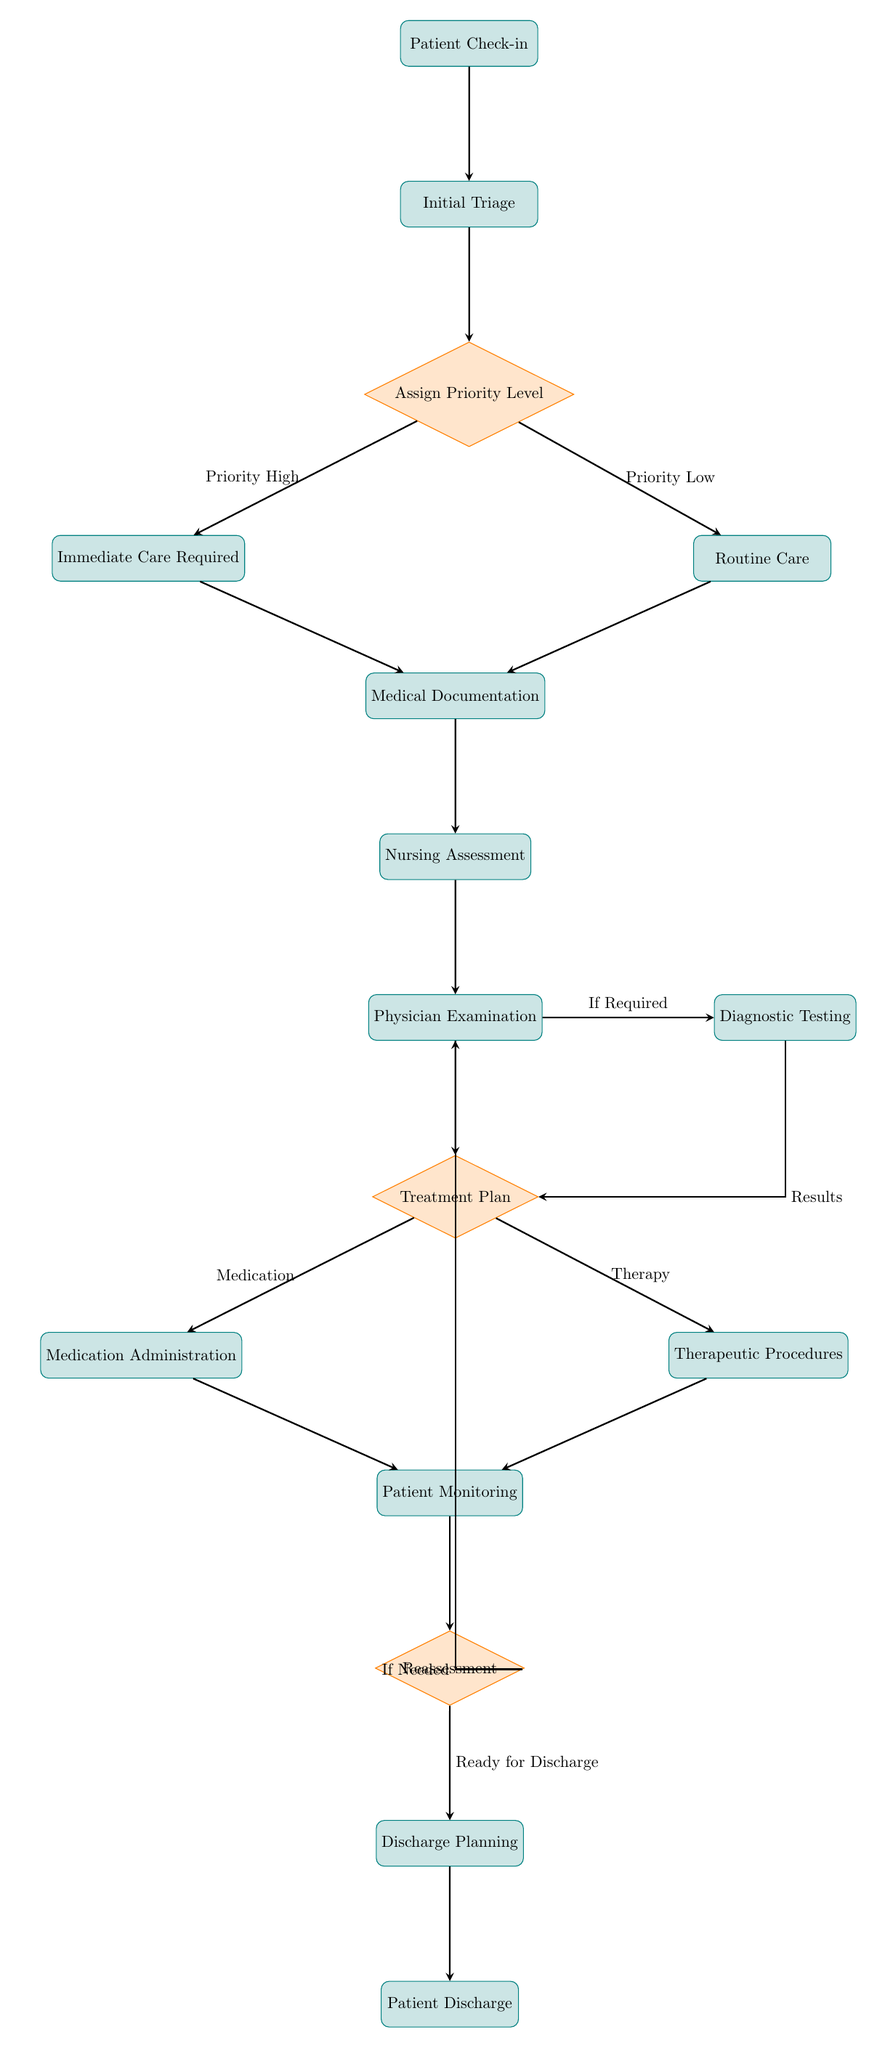What is the first step in the patient care workflow? The first step, according to the flowchart, is "Patient Check-in," which is the starting point of the process.
Answer: Patient Check-in How many decision points are in the diagram? Upon reviewing the flowchart, there are four decision points marked as diamonds. These are "Assign Priority Level," "Treatment Plan," and "Reassessment," which affect the flow of the process.
Answer: 4 What happens if immediate care is required? If "Immediate Care Required" is selected at the "Assign Priority Level" decision point, the workflow moves to "Medical Documentation," continuing through the patient care process.
Answer: Medical Documentation What is the outcome of the "Reassessment" decision point if the patient is ready for discharge? If the patient is "Ready for Discharge," the workflow continues to "Discharge Planning," which is the next step after reassessment.
Answer: Discharge Planning Which two processes follow the "Physician Examination" step? After "Physician Examination," the next steps are "Diagnostic Testing" and "Treatment Plan," indicating subsequent care processes.
Answer: Diagnostic Testing and Treatment Plan What is required documentation immediately after receiving care? The required documentation immediately after receiving care, following either "Immediate Care Required" or "Routine Care," is "Medical Documentation."
Answer: Medical Documentation What is the last step in the patient care workflow? The last step in the sequence of tasks is "Patient Discharge," marking the completion of the patient care workflow.
Answer: Patient Discharge What type of care does "Therapeutic Procedures" involve? "Therapeutic Procedures" involves actions taken after the "Treatment Plan" decision point, specifically aimed at providing therapies as outlined in the treatment plan.
Answer: Therapy If diagnostic testing is required, what is the subsequent step? After diagnostic testing, the flow indicates that results will lead to the "Treatment Plan" decision point, where the next actions will be determined based on the results.
Answer: Treatment Plan 